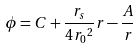Convert formula to latex. <formula><loc_0><loc_0><loc_500><loc_500>\phi = C + \frac { r _ { s } } { 4 { r _ { 0 } } ^ { 2 } } r - \frac { A } { r }</formula> 